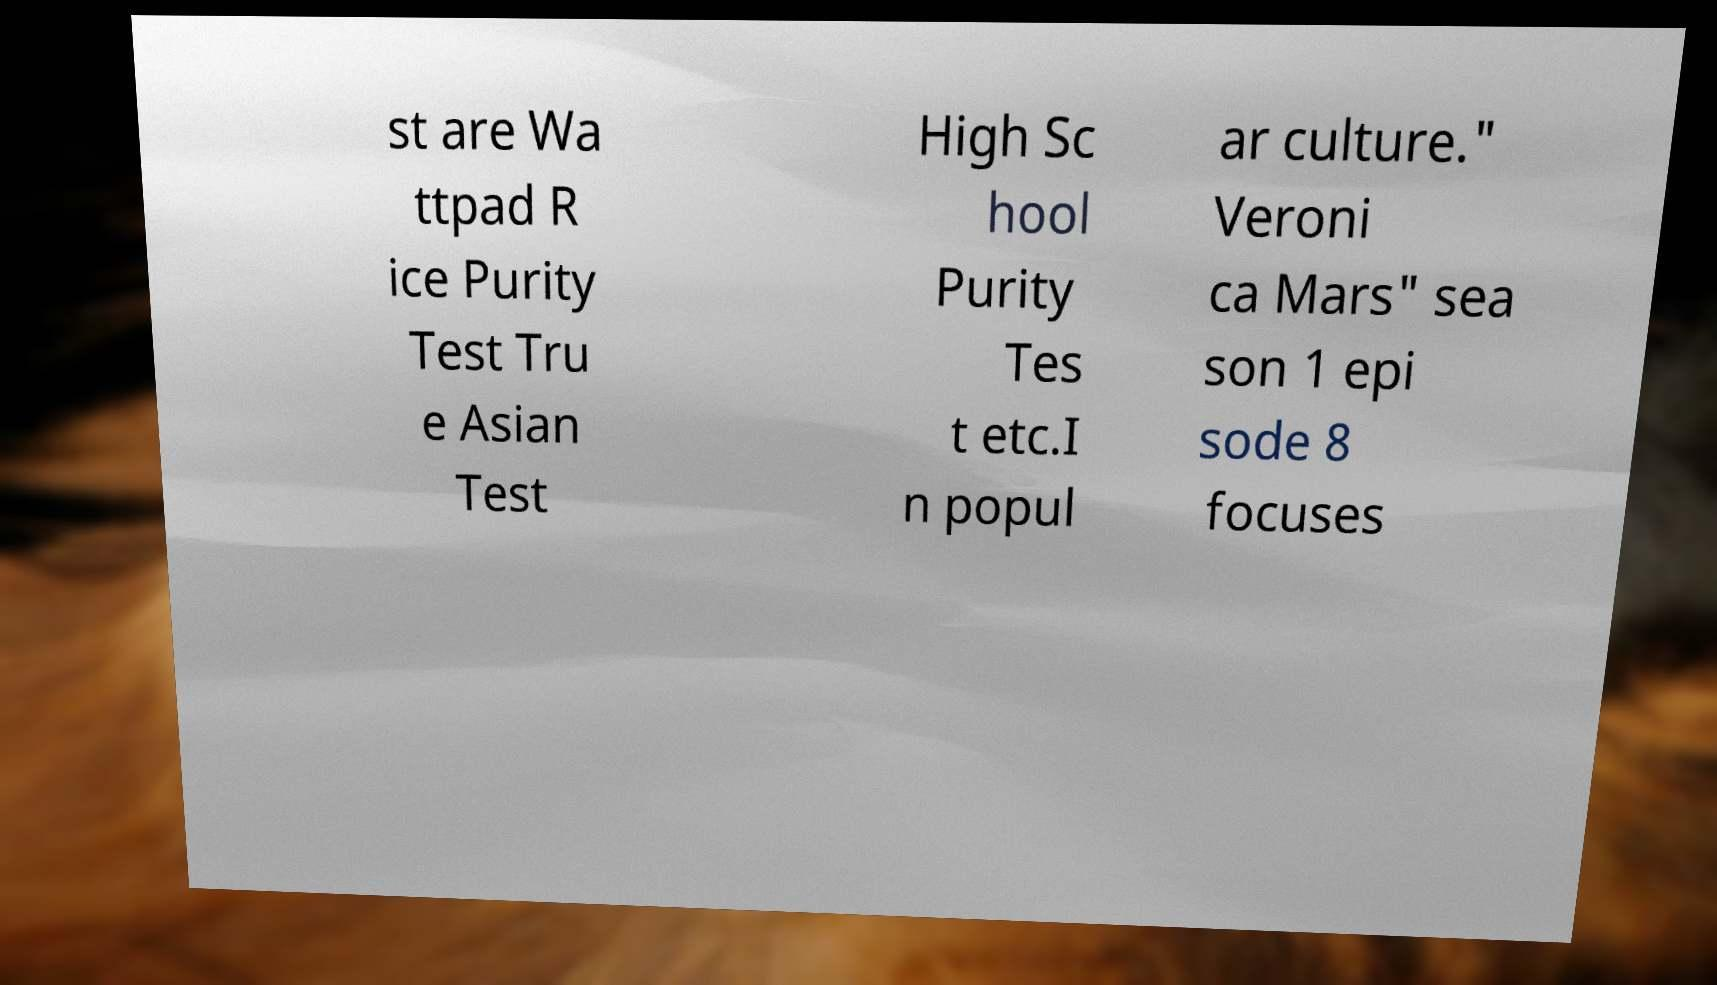I need the written content from this picture converted into text. Can you do that? st are Wa ttpad R ice Purity Test Tru e Asian Test High Sc hool Purity Tes t etc.I n popul ar culture." Veroni ca Mars" sea son 1 epi sode 8 focuses 